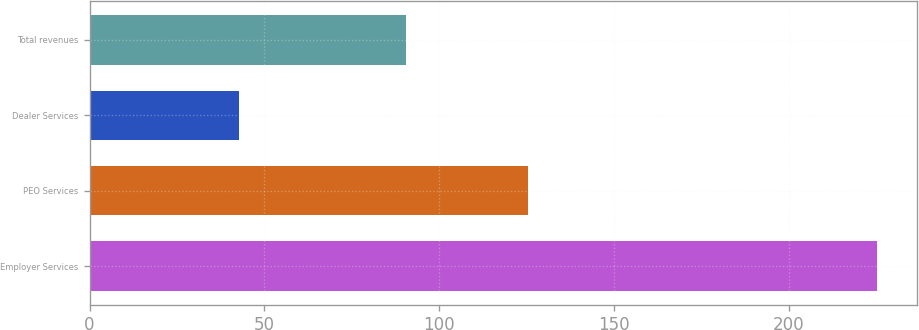Convert chart. <chart><loc_0><loc_0><loc_500><loc_500><bar_chart><fcel>Employer Services<fcel>PEO Services<fcel>Dealer Services<fcel>Total revenues<nl><fcel>225.3<fcel>125.3<fcel>42.8<fcel>90.6<nl></chart> 